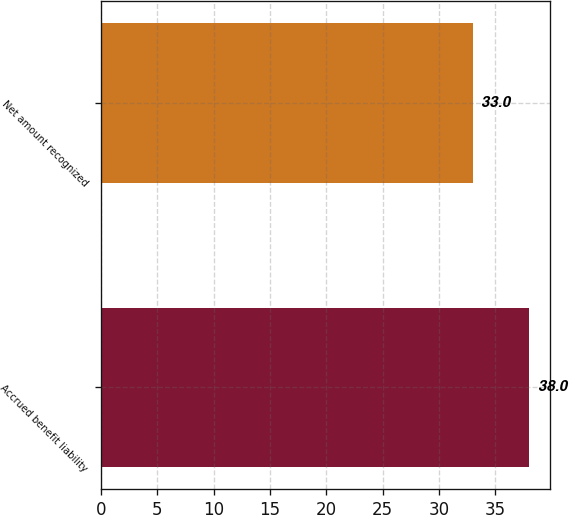<chart> <loc_0><loc_0><loc_500><loc_500><bar_chart><fcel>Accrued benefit liability<fcel>Net amount recognized<nl><fcel>38<fcel>33<nl></chart> 